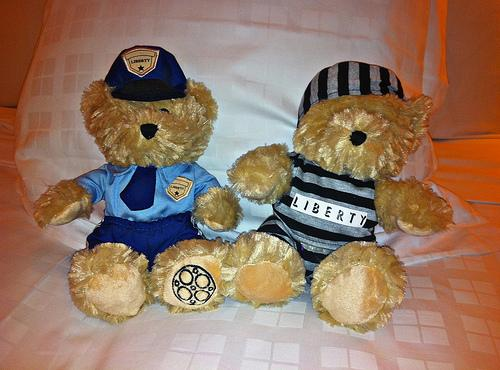Create a one-line description of the image. A teddy bear duo, one embodying law and order and the other standing for mischief, share a moment on a comfortable bed. Provide a short description of the scene depicted in the image. Two teddy bears, one dressed as a policeman and the other as a prisoner, are sitting on a bed with a white pillow behind them. Describe the image as if narrating it to a young child. A friendly teddy bear policeman and a mischievous teddy bear prisoner are sitting together on a big, cozy bed, leaning on a pillow. Describe the attire and position of the teddy bears in the image. One teddy bear in a police outfit sits next to another wearing a prisoner outfit, both leaning on a pillow on the bed. Using simple language, explain what can be seen in the image. Two teddy bears, one dressed like a cop and the other like a prisoner, are sitting on a bed. Briefly describe the appearance of the teddy bears in the image. Two brown teddy bears, one donning a police uniform and another in a prisoner outfit, are situated on a bed. Mention the outfits that the teddy bears are wearing in the image. One teddy bear is wearing a police uniform with a blue tie and hat, while the other is wearing a black and grey striped prison outfit. Explain the setting where the two teddy bears are located. The teddy bears are sitting on a bed, leaning against a white pillow with a light shining from the side. Identify the two main subjects of the image and their attire. A teddy bear policeman wearing a blue hat and tie, and a teddy bear prisoner dressed in black and grey stripes. In a poetic manner, describe the scene depicted in the image. Upon the soft and cozy bed, two charming teddy bears reside; one dressed in blue stands guard, the other in stripes hides. 